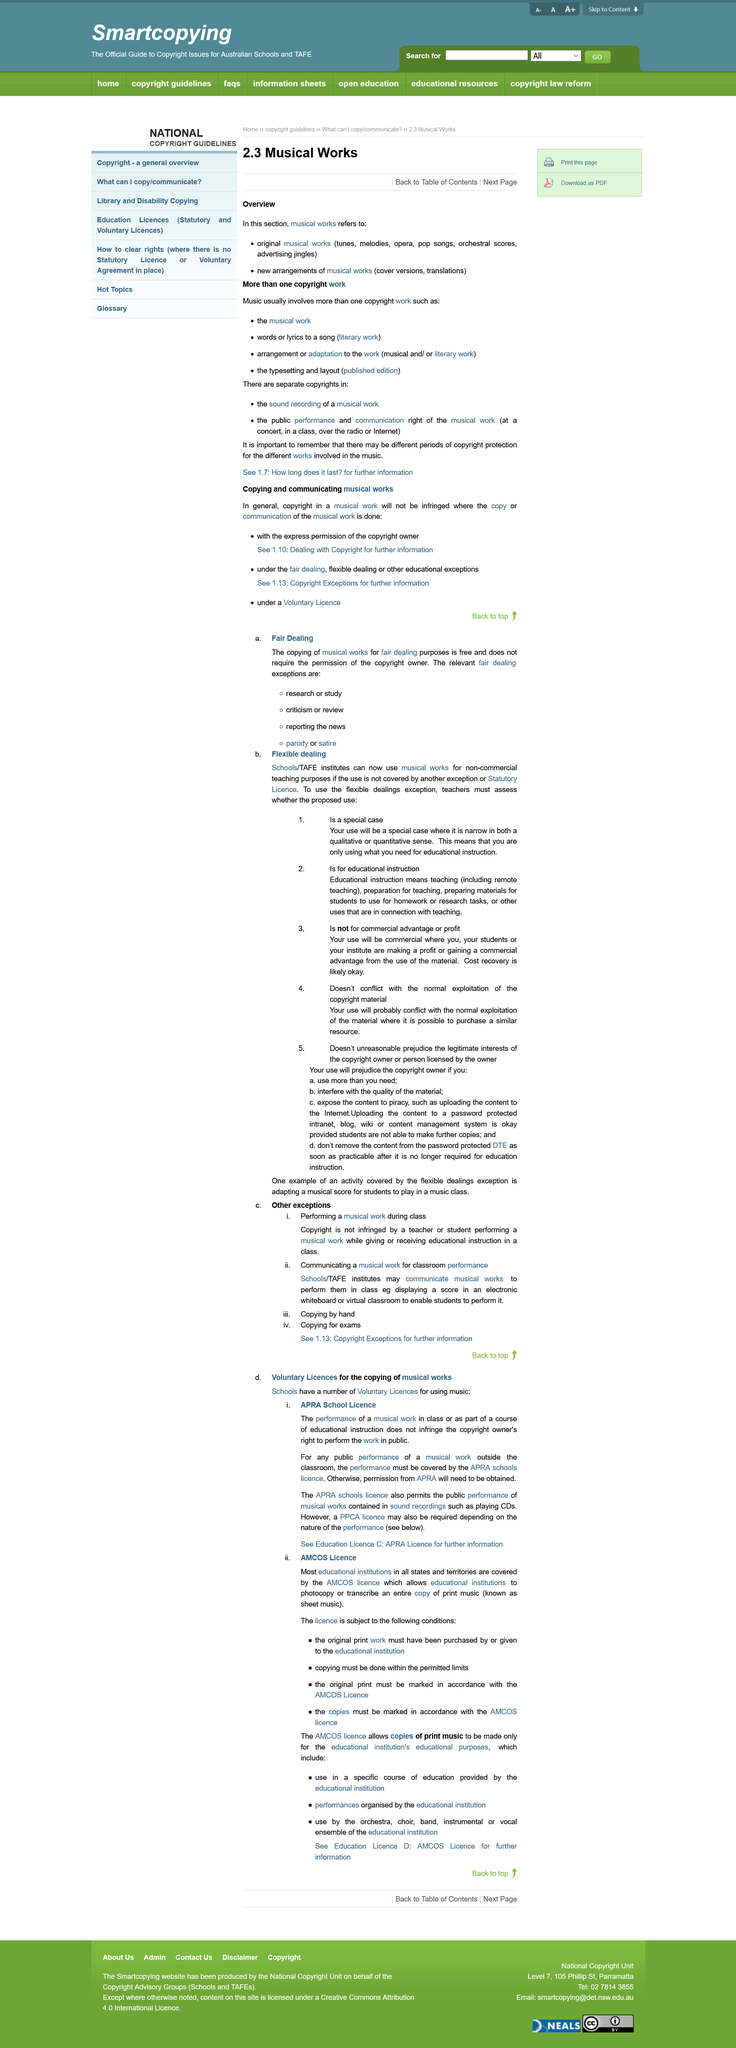Point out several critical features in this image. The use or performance of musical work as part of a course of educational instruction in schools does not infringe copyright. The title discusses voluntary licenses for the copying of musical works, which is a type of copyright license. Original musical works and new arrangements of musical works are the different types of musical works. It is necessary to obtain permission from the Australian Performing Rights Association (APRA) in order to perform a musical work outside of the classroom. Original musical works are a diverse and varied collection of compositions, including tunes, melodies, opera, pop songs, orchestral scores, and advertising jingles. 